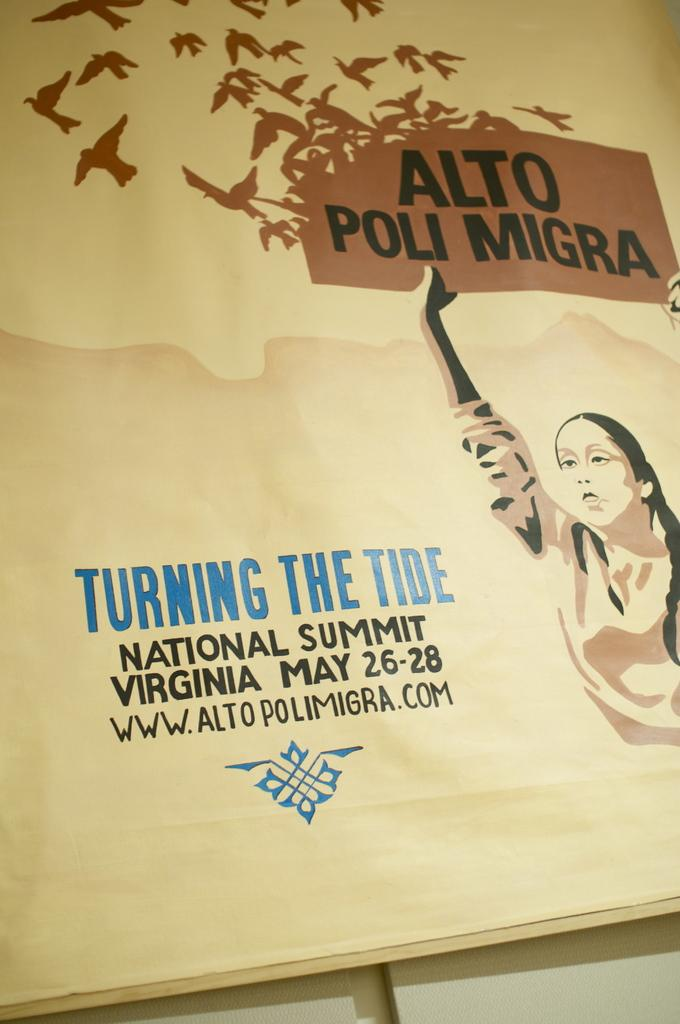What is the main object in the image? There is a board in the image. What can be seen on the board? There is writing on the board and pictures of birds and a woman. Is there any coal visible on the board in the image? No, there is no coal present on the board in the image. What type of class is being taught in the image? The image does not show a class or any indication of a class being taught. 